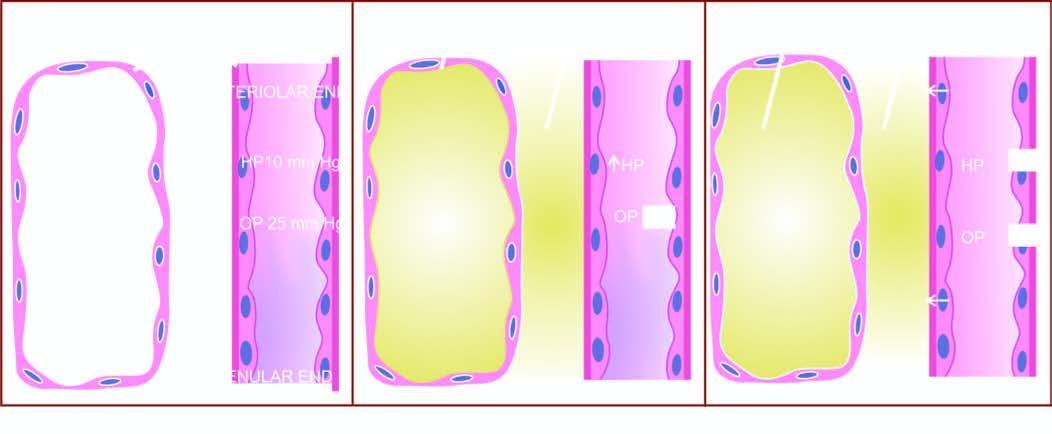re mechanisms involved in the pathogenesis of cardiac oedema?
Answer the question using a single word or phrase. Yes 